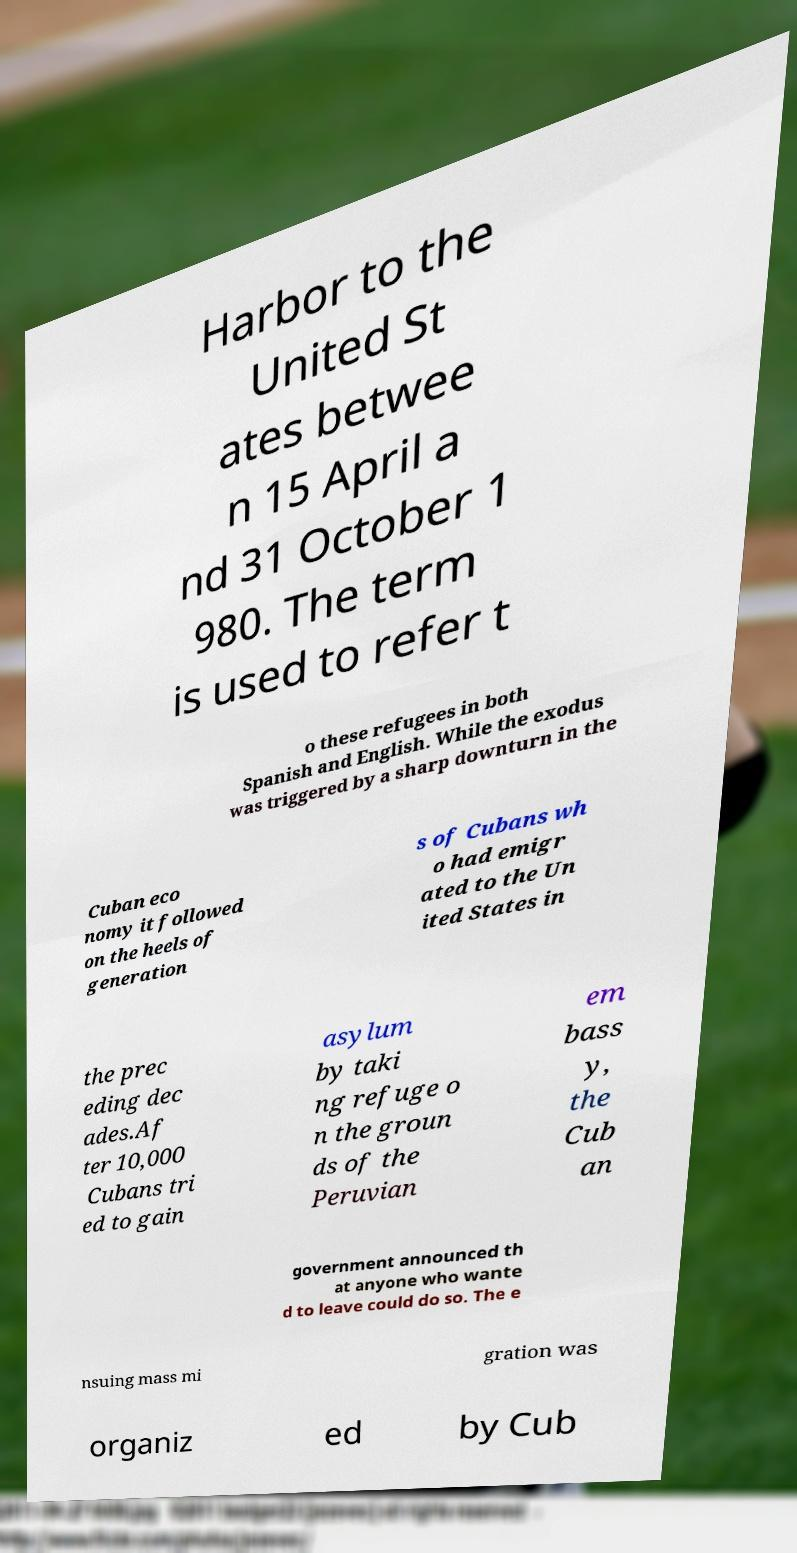There's text embedded in this image that I need extracted. Can you transcribe it verbatim? Harbor to the United St ates betwee n 15 April a nd 31 October 1 980. The term is used to refer t o these refugees in both Spanish and English. While the exodus was triggered by a sharp downturn in the Cuban eco nomy it followed on the heels of generation s of Cubans wh o had emigr ated to the Un ited States in the prec eding dec ades.Af ter 10,000 Cubans tri ed to gain asylum by taki ng refuge o n the groun ds of the Peruvian em bass y, the Cub an government announced th at anyone who wante d to leave could do so. The e nsuing mass mi gration was organiz ed by Cub 